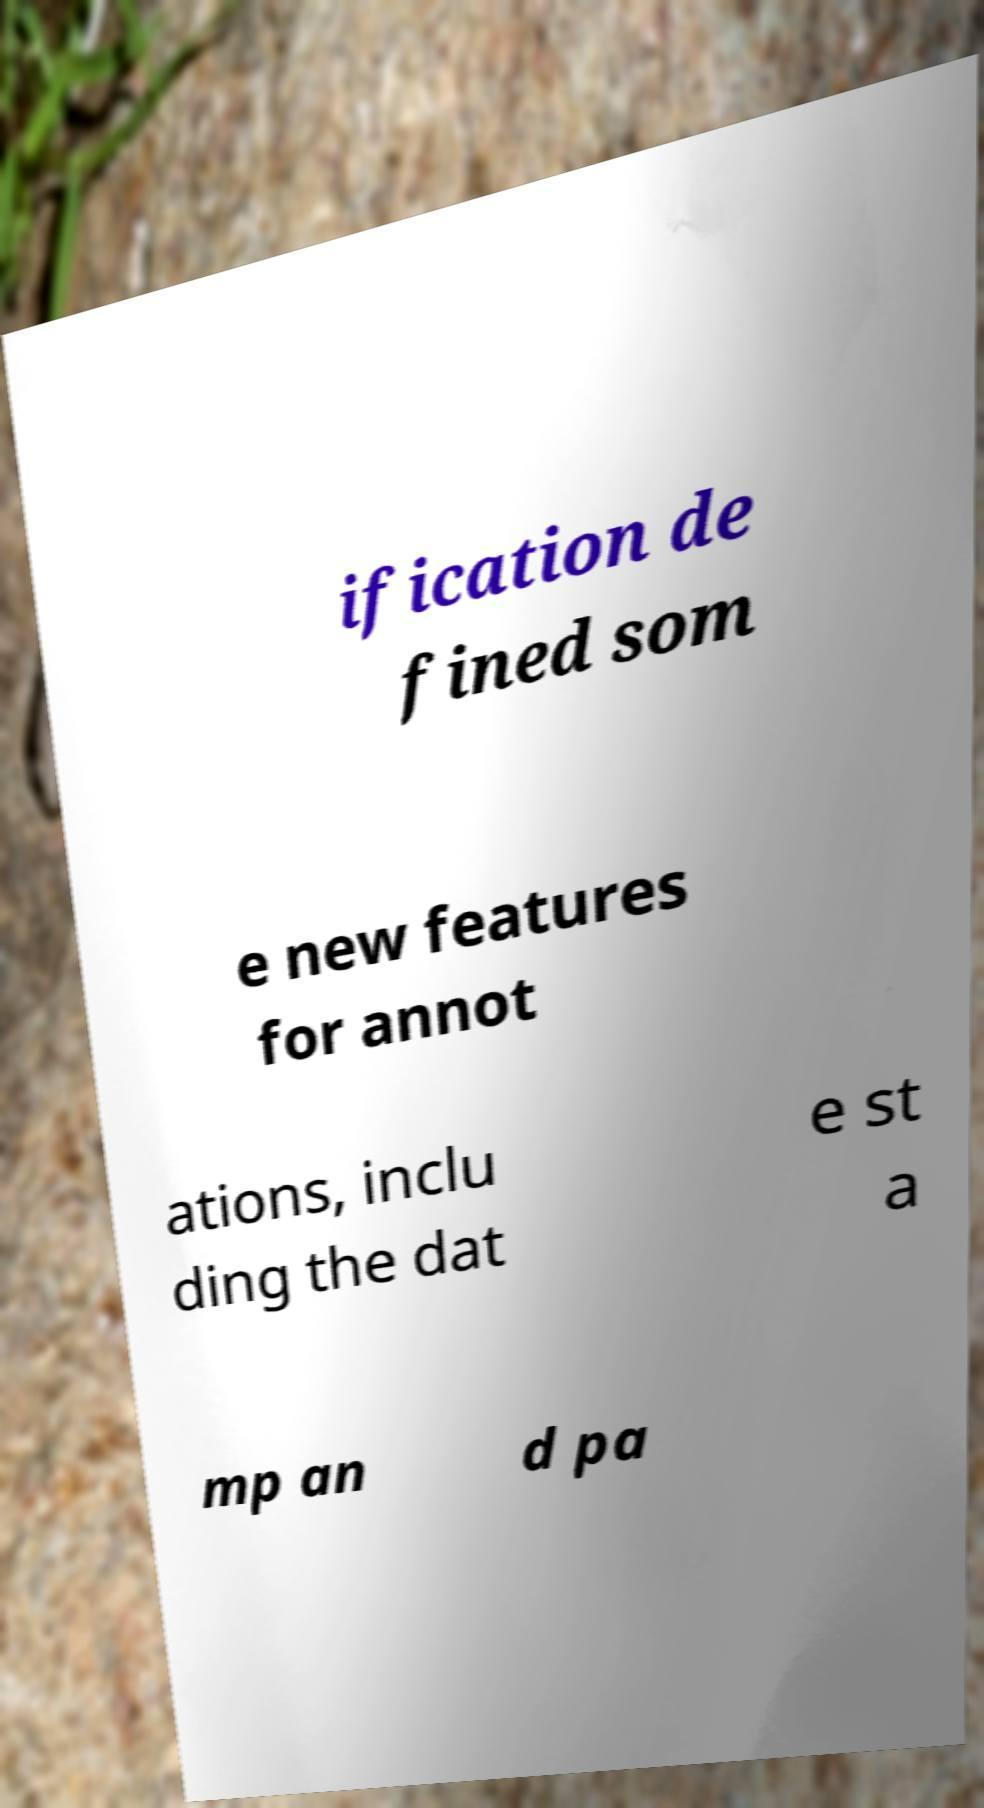Can you accurately transcribe the text from the provided image for me? ification de fined som e new features for annot ations, inclu ding the dat e st a mp an d pa 